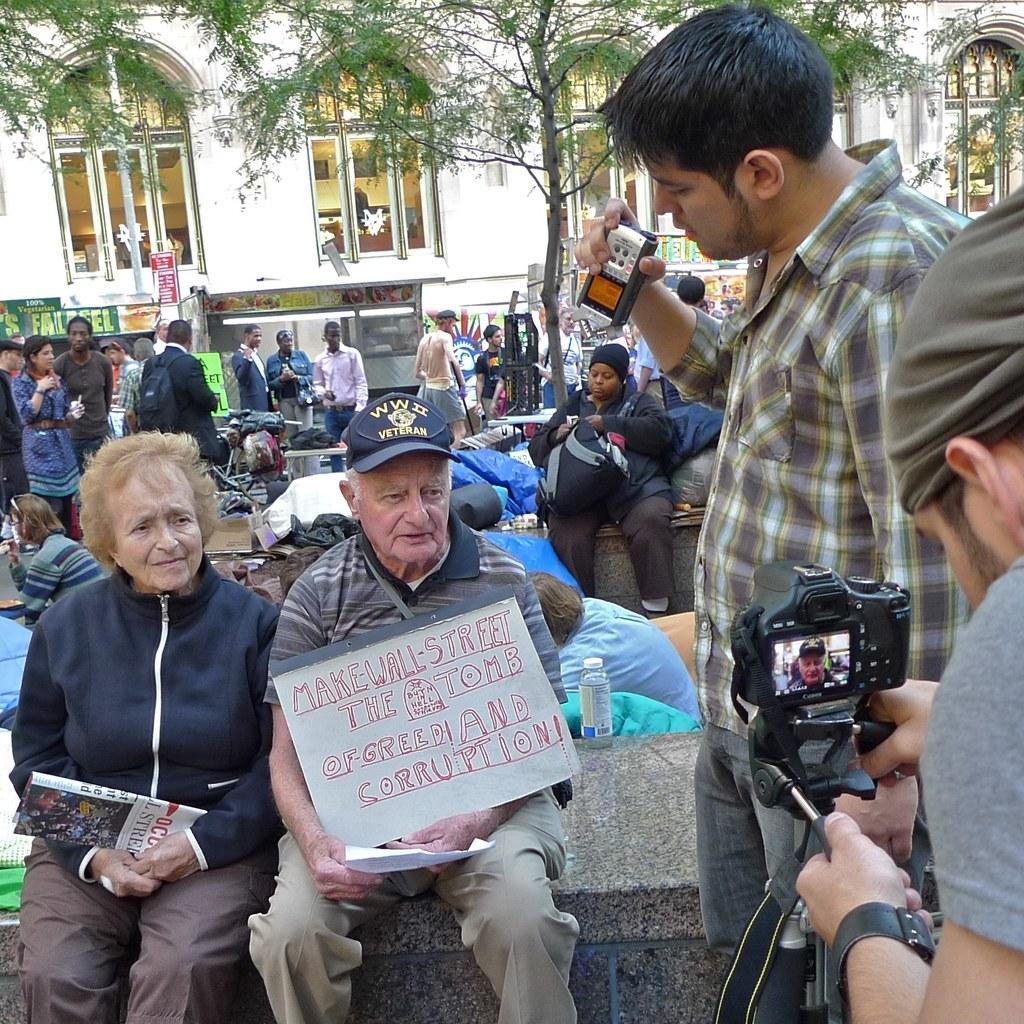Can you describe this image briefly? There is a person on the right side. He is taking a video of this people who are sitting on the left side. In the background we can see a group of people who are standing. We can see a house and a tree. 